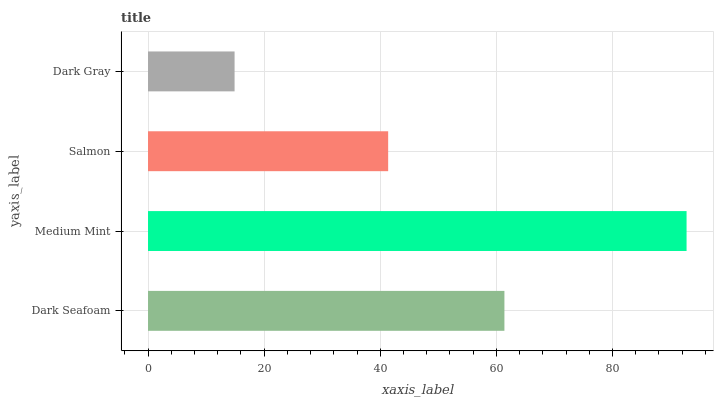Is Dark Gray the minimum?
Answer yes or no. Yes. Is Medium Mint the maximum?
Answer yes or no. Yes. Is Salmon the minimum?
Answer yes or no. No. Is Salmon the maximum?
Answer yes or no. No. Is Medium Mint greater than Salmon?
Answer yes or no. Yes. Is Salmon less than Medium Mint?
Answer yes or no. Yes. Is Salmon greater than Medium Mint?
Answer yes or no. No. Is Medium Mint less than Salmon?
Answer yes or no. No. Is Dark Seafoam the high median?
Answer yes or no. Yes. Is Salmon the low median?
Answer yes or no. Yes. Is Dark Gray the high median?
Answer yes or no. No. Is Medium Mint the low median?
Answer yes or no. No. 